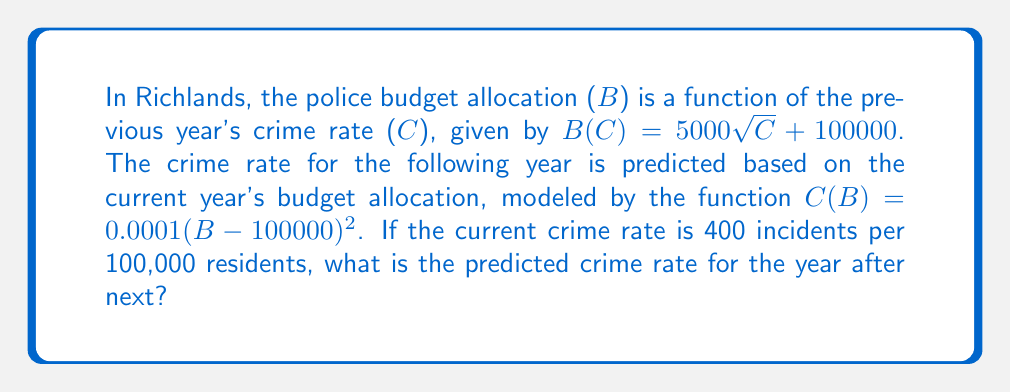Solve this math problem. To solve this problem, we need to compute the composition of functions. Let's break it down step-by-step:

1. Start with the current crime rate: $C = 400$

2. Calculate next year's budget allocation using $B(C)$:
   $B(400) = 5000\sqrt{400} + 100000$
   $= 5000 \cdot 20 + 100000$
   $= 100000 + 100000 = 200000$

3. Now, we use this budget to predict the following year's crime rate using $C(B)$:
   $C(B(400)) = 0.0001(200000-100000)^2$
   $= 0.0001(100000)^2$
   $= 0.0001 \cdot 10000000000$
   $= 1000000$

4. Therefore, the predicted crime rate for the year after next is 1,000,000 incidents per 100,000 residents.

This composition of functions can be written as $(C \circ B)(400)$ or $C(B(400))$.

Note: This result, while mathematically correct based on the given functions, yields an unrealistically high crime rate. In a real-world scenario, a resident critical of police activities might question the validity of these predictive models and their implications for budget allocation.
Answer: The predicted crime rate for the year after next is 1,000,000 incidents per 100,000 residents. 